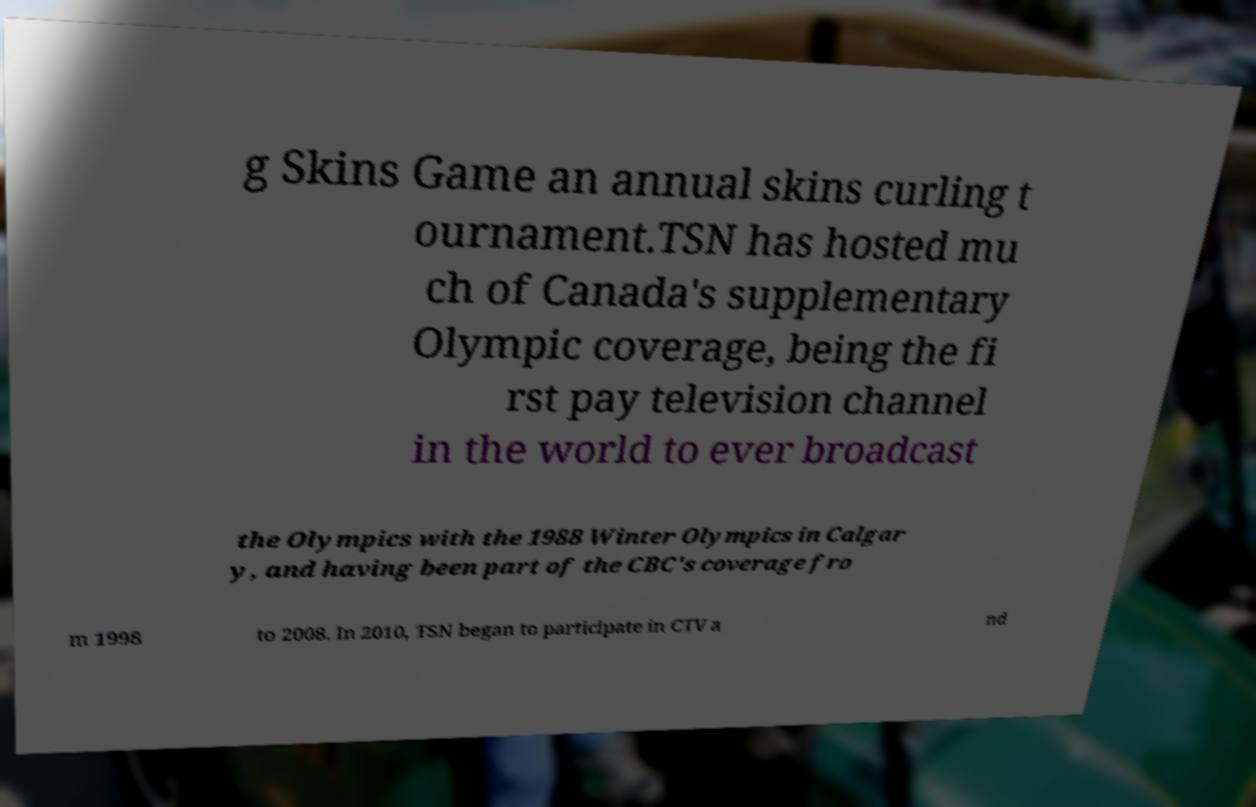Can you accurately transcribe the text from the provided image for me? g Skins Game an annual skins curling t ournament.TSN has hosted mu ch of Canada's supplementary Olympic coverage, being the fi rst pay television channel in the world to ever broadcast the Olympics with the 1988 Winter Olympics in Calgar y, and having been part of the CBC's coverage fro m 1998 to 2008. In 2010, TSN began to participate in CTV a nd 